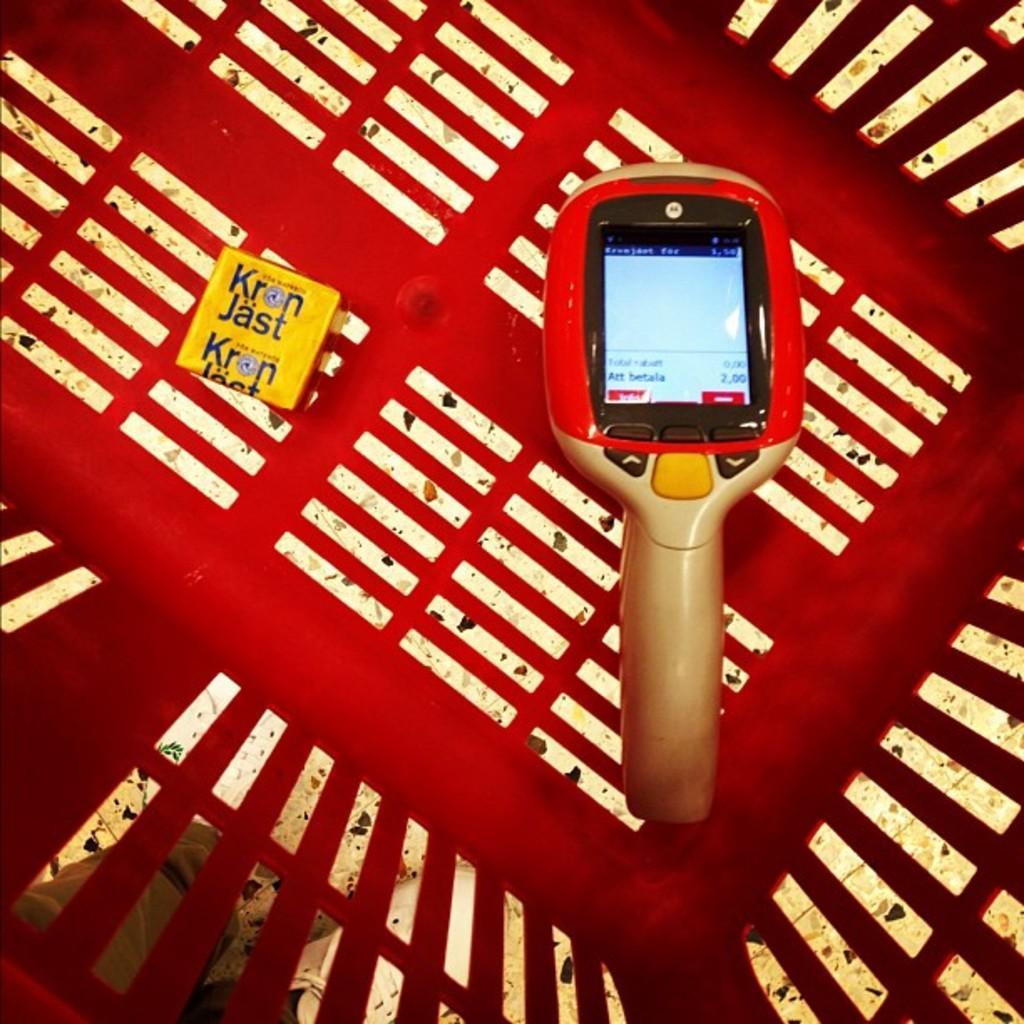Can you describe this image briefly? In this image there is a machine having a screen and a box are in the basket. Behind the basket there is a person wearing shoes and pant is standing on the floor. 